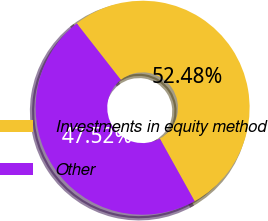Convert chart to OTSL. <chart><loc_0><loc_0><loc_500><loc_500><pie_chart><fcel>Investments in equity method<fcel>Other<nl><fcel>52.48%<fcel>47.52%<nl></chart> 